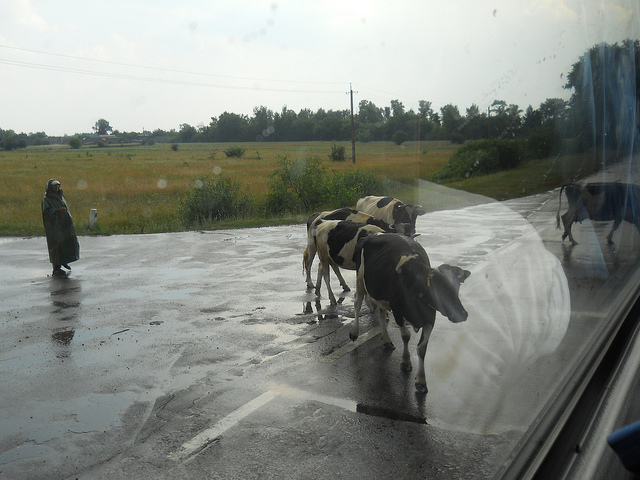What is the weather like in this image? The weather looks overcast, with a wet road surface suggesting recent rain. There's a soft brightness that might be signaling the potential clearing of the skies. 